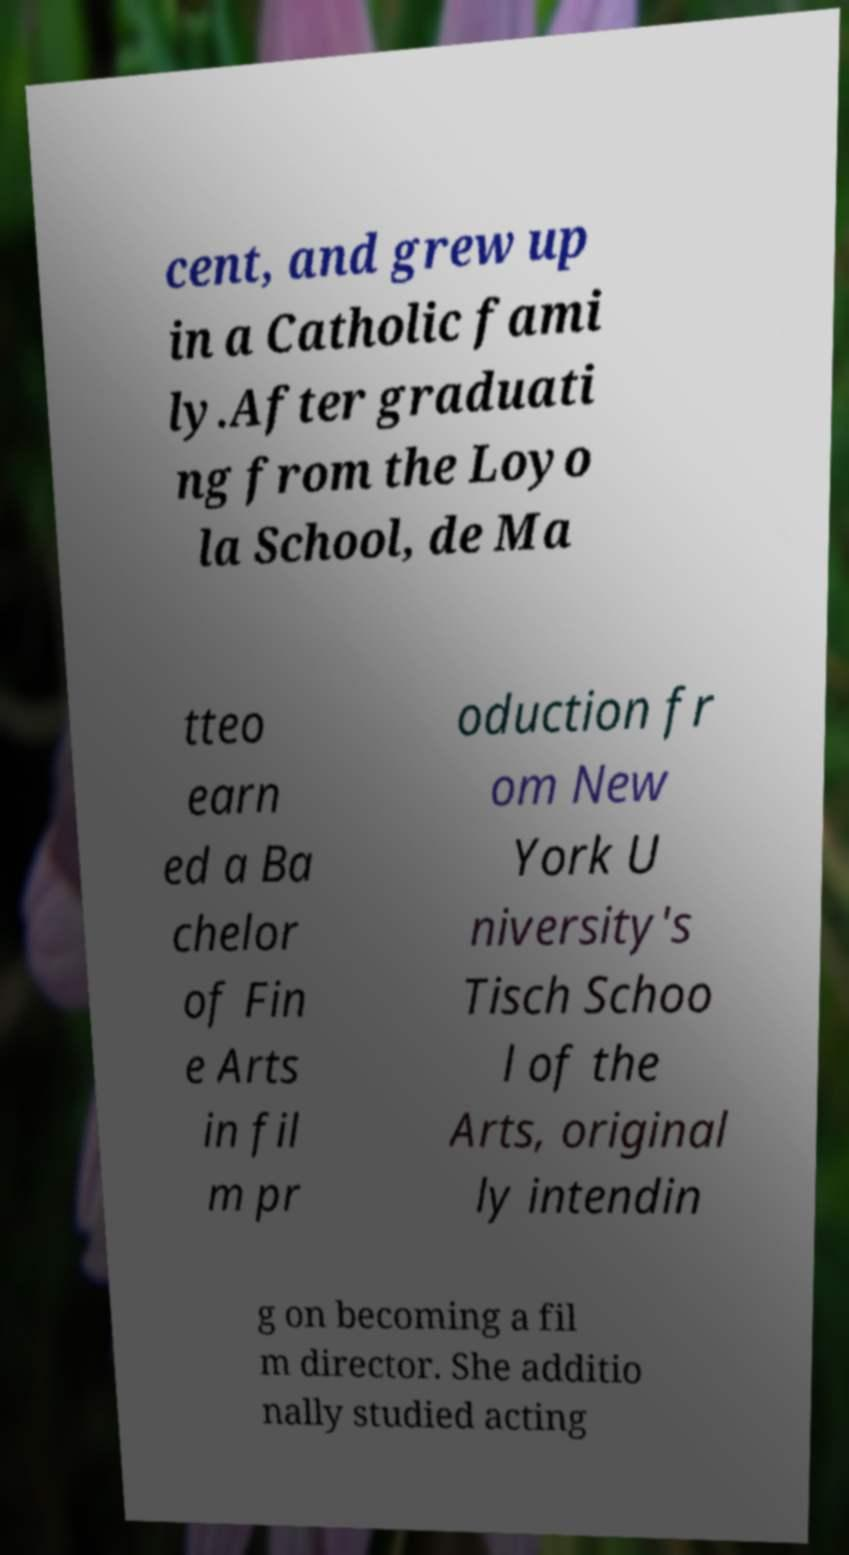Please identify and transcribe the text found in this image. cent, and grew up in a Catholic fami ly.After graduati ng from the Loyo la School, de Ma tteo earn ed a Ba chelor of Fin e Arts in fil m pr oduction fr om New York U niversity's Tisch Schoo l of the Arts, original ly intendin g on becoming a fil m director. She additio nally studied acting 